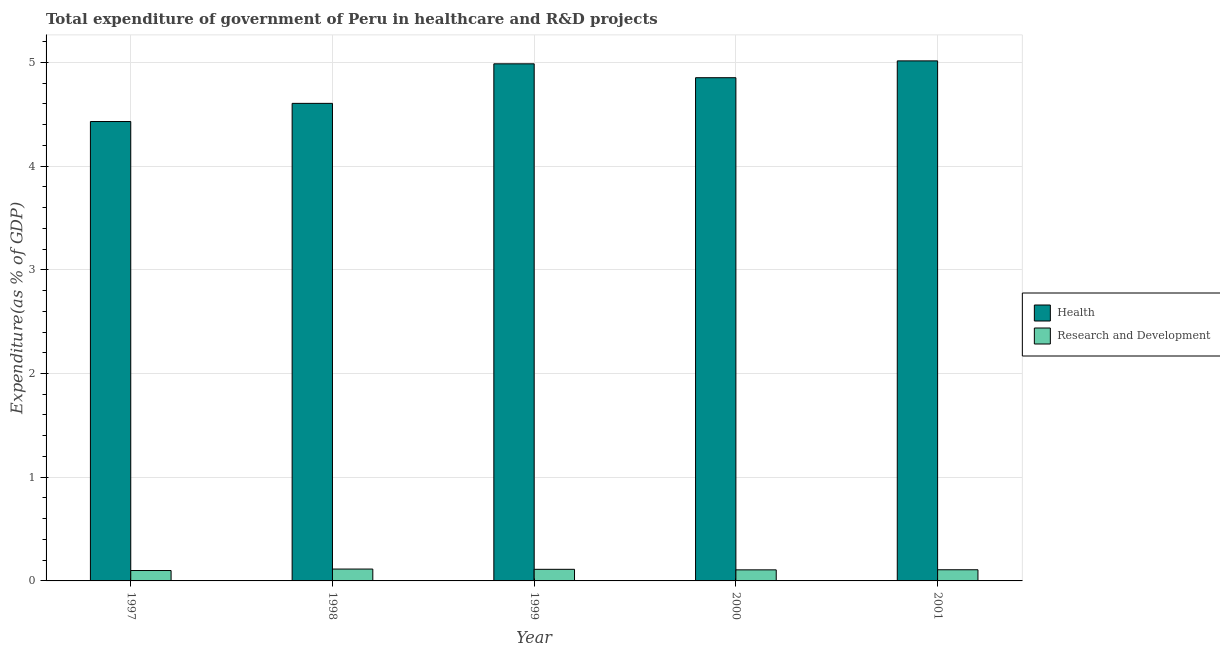How many groups of bars are there?
Keep it short and to the point. 5. Are the number of bars on each tick of the X-axis equal?
Provide a short and direct response. Yes. In how many cases, is the number of bars for a given year not equal to the number of legend labels?
Keep it short and to the point. 0. What is the expenditure in healthcare in 2000?
Your answer should be very brief. 4.85. Across all years, what is the maximum expenditure in r&d?
Your answer should be very brief. 0.11. Across all years, what is the minimum expenditure in r&d?
Your answer should be very brief. 0.1. In which year was the expenditure in healthcare maximum?
Provide a succinct answer. 2001. What is the total expenditure in healthcare in the graph?
Give a very brief answer. 23.89. What is the difference between the expenditure in r&d in 1999 and that in 2000?
Keep it short and to the point. 0.01. What is the difference between the expenditure in healthcare in 1998 and the expenditure in r&d in 1999?
Your answer should be compact. -0.38. What is the average expenditure in healthcare per year?
Your response must be concise. 4.78. In the year 2000, what is the difference between the expenditure in r&d and expenditure in healthcare?
Your answer should be very brief. 0. In how many years, is the expenditure in r&d greater than 2.2 %?
Keep it short and to the point. 0. What is the ratio of the expenditure in r&d in 2000 to that in 2001?
Your answer should be compact. 0.99. Is the expenditure in r&d in 1998 less than that in 2000?
Offer a terse response. No. What is the difference between the highest and the second highest expenditure in healthcare?
Give a very brief answer. 0.03. What is the difference between the highest and the lowest expenditure in healthcare?
Offer a terse response. 0.58. In how many years, is the expenditure in r&d greater than the average expenditure in r&d taken over all years?
Offer a terse response. 2. What does the 2nd bar from the left in 2000 represents?
Your answer should be compact. Research and Development. What does the 1st bar from the right in 2001 represents?
Give a very brief answer. Research and Development. How many bars are there?
Give a very brief answer. 10. Are the values on the major ticks of Y-axis written in scientific E-notation?
Give a very brief answer. No. Does the graph contain any zero values?
Make the answer very short. No. Does the graph contain grids?
Provide a succinct answer. Yes. What is the title of the graph?
Provide a succinct answer. Total expenditure of government of Peru in healthcare and R&D projects. Does "GDP at market prices" appear as one of the legend labels in the graph?
Offer a very short reply. No. What is the label or title of the Y-axis?
Provide a short and direct response. Expenditure(as % of GDP). What is the Expenditure(as % of GDP) of Health in 1997?
Your answer should be very brief. 4.43. What is the Expenditure(as % of GDP) in Research and Development in 1997?
Offer a terse response. 0.1. What is the Expenditure(as % of GDP) of Health in 1998?
Your response must be concise. 4.6. What is the Expenditure(as % of GDP) of Research and Development in 1998?
Provide a succinct answer. 0.11. What is the Expenditure(as % of GDP) of Health in 1999?
Offer a very short reply. 4.99. What is the Expenditure(as % of GDP) in Research and Development in 1999?
Make the answer very short. 0.11. What is the Expenditure(as % of GDP) in Health in 2000?
Ensure brevity in your answer.  4.85. What is the Expenditure(as % of GDP) in Research and Development in 2000?
Your answer should be compact. 0.11. What is the Expenditure(as % of GDP) of Health in 2001?
Your answer should be compact. 5.01. What is the Expenditure(as % of GDP) in Research and Development in 2001?
Ensure brevity in your answer.  0.11. Across all years, what is the maximum Expenditure(as % of GDP) of Health?
Provide a short and direct response. 5.01. Across all years, what is the maximum Expenditure(as % of GDP) in Research and Development?
Keep it short and to the point. 0.11. Across all years, what is the minimum Expenditure(as % of GDP) of Health?
Keep it short and to the point. 4.43. Across all years, what is the minimum Expenditure(as % of GDP) in Research and Development?
Offer a very short reply. 0.1. What is the total Expenditure(as % of GDP) of Health in the graph?
Your answer should be compact. 23.89. What is the total Expenditure(as % of GDP) in Research and Development in the graph?
Offer a terse response. 0.54. What is the difference between the Expenditure(as % of GDP) in Health in 1997 and that in 1998?
Keep it short and to the point. -0.17. What is the difference between the Expenditure(as % of GDP) of Research and Development in 1997 and that in 1998?
Make the answer very short. -0.01. What is the difference between the Expenditure(as % of GDP) of Health in 1997 and that in 1999?
Keep it short and to the point. -0.56. What is the difference between the Expenditure(as % of GDP) of Research and Development in 1997 and that in 1999?
Provide a short and direct response. -0.01. What is the difference between the Expenditure(as % of GDP) of Health in 1997 and that in 2000?
Your answer should be compact. -0.42. What is the difference between the Expenditure(as % of GDP) in Research and Development in 1997 and that in 2000?
Give a very brief answer. -0.01. What is the difference between the Expenditure(as % of GDP) in Health in 1997 and that in 2001?
Your answer should be compact. -0.58. What is the difference between the Expenditure(as % of GDP) of Research and Development in 1997 and that in 2001?
Provide a succinct answer. -0.01. What is the difference between the Expenditure(as % of GDP) of Health in 1998 and that in 1999?
Make the answer very short. -0.38. What is the difference between the Expenditure(as % of GDP) in Research and Development in 1998 and that in 1999?
Make the answer very short. 0. What is the difference between the Expenditure(as % of GDP) of Health in 1998 and that in 2000?
Make the answer very short. -0.25. What is the difference between the Expenditure(as % of GDP) in Research and Development in 1998 and that in 2000?
Ensure brevity in your answer.  0.01. What is the difference between the Expenditure(as % of GDP) in Health in 1998 and that in 2001?
Keep it short and to the point. -0.41. What is the difference between the Expenditure(as % of GDP) in Research and Development in 1998 and that in 2001?
Make the answer very short. 0.01. What is the difference between the Expenditure(as % of GDP) of Health in 1999 and that in 2000?
Provide a short and direct response. 0.13. What is the difference between the Expenditure(as % of GDP) in Research and Development in 1999 and that in 2000?
Your answer should be compact. 0.01. What is the difference between the Expenditure(as % of GDP) in Health in 1999 and that in 2001?
Provide a succinct answer. -0.03. What is the difference between the Expenditure(as % of GDP) of Research and Development in 1999 and that in 2001?
Offer a terse response. 0. What is the difference between the Expenditure(as % of GDP) of Health in 2000 and that in 2001?
Provide a short and direct response. -0.16. What is the difference between the Expenditure(as % of GDP) in Research and Development in 2000 and that in 2001?
Your answer should be very brief. -0. What is the difference between the Expenditure(as % of GDP) in Health in 1997 and the Expenditure(as % of GDP) in Research and Development in 1998?
Your answer should be compact. 4.32. What is the difference between the Expenditure(as % of GDP) in Health in 1997 and the Expenditure(as % of GDP) in Research and Development in 1999?
Offer a very short reply. 4.32. What is the difference between the Expenditure(as % of GDP) of Health in 1997 and the Expenditure(as % of GDP) of Research and Development in 2000?
Your answer should be compact. 4.32. What is the difference between the Expenditure(as % of GDP) in Health in 1997 and the Expenditure(as % of GDP) in Research and Development in 2001?
Your answer should be compact. 4.32. What is the difference between the Expenditure(as % of GDP) in Health in 1998 and the Expenditure(as % of GDP) in Research and Development in 1999?
Keep it short and to the point. 4.49. What is the difference between the Expenditure(as % of GDP) in Health in 1998 and the Expenditure(as % of GDP) in Research and Development in 2000?
Give a very brief answer. 4.5. What is the difference between the Expenditure(as % of GDP) in Health in 1998 and the Expenditure(as % of GDP) in Research and Development in 2001?
Offer a terse response. 4.5. What is the difference between the Expenditure(as % of GDP) of Health in 1999 and the Expenditure(as % of GDP) of Research and Development in 2000?
Your response must be concise. 4.88. What is the difference between the Expenditure(as % of GDP) of Health in 1999 and the Expenditure(as % of GDP) of Research and Development in 2001?
Ensure brevity in your answer.  4.88. What is the difference between the Expenditure(as % of GDP) in Health in 2000 and the Expenditure(as % of GDP) in Research and Development in 2001?
Your answer should be compact. 4.74. What is the average Expenditure(as % of GDP) in Health per year?
Your response must be concise. 4.78. What is the average Expenditure(as % of GDP) of Research and Development per year?
Provide a succinct answer. 0.11. In the year 1997, what is the difference between the Expenditure(as % of GDP) of Health and Expenditure(as % of GDP) of Research and Development?
Ensure brevity in your answer.  4.33. In the year 1998, what is the difference between the Expenditure(as % of GDP) of Health and Expenditure(as % of GDP) of Research and Development?
Give a very brief answer. 4.49. In the year 1999, what is the difference between the Expenditure(as % of GDP) in Health and Expenditure(as % of GDP) in Research and Development?
Ensure brevity in your answer.  4.87. In the year 2000, what is the difference between the Expenditure(as % of GDP) in Health and Expenditure(as % of GDP) in Research and Development?
Ensure brevity in your answer.  4.75. In the year 2001, what is the difference between the Expenditure(as % of GDP) of Health and Expenditure(as % of GDP) of Research and Development?
Provide a short and direct response. 4.91. What is the ratio of the Expenditure(as % of GDP) in Health in 1997 to that in 1998?
Give a very brief answer. 0.96. What is the ratio of the Expenditure(as % of GDP) in Research and Development in 1997 to that in 1998?
Offer a terse response. 0.88. What is the ratio of the Expenditure(as % of GDP) in Health in 1997 to that in 1999?
Provide a succinct answer. 0.89. What is the ratio of the Expenditure(as % of GDP) in Research and Development in 1997 to that in 1999?
Provide a succinct answer. 0.9. What is the ratio of the Expenditure(as % of GDP) in Health in 1997 to that in 2000?
Give a very brief answer. 0.91. What is the ratio of the Expenditure(as % of GDP) of Research and Development in 1997 to that in 2000?
Keep it short and to the point. 0.94. What is the ratio of the Expenditure(as % of GDP) of Health in 1997 to that in 2001?
Provide a short and direct response. 0.88. What is the ratio of the Expenditure(as % of GDP) of Research and Development in 1997 to that in 2001?
Make the answer very short. 0.93. What is the ratio of the Expenditure(as % of GDP) in Health in 1998 to that in 1999?
Give a very brief answer. 0.92. What is the ratio of the Expenditure(as % of GDP) of Research and Development in 1998 to that in 1999?
Your answer should be very brief. 1.02. What is the ratio of the Expenditure(as % of GDP) in Health in 1998 to that in 2000?
Your answer should be compact. 0.95. What is the ratio of the Expenditure(as % of GDP) of Research and Development in 1998 to that in 2000?
Ensure brevity in your answer.  1.07. What is the ratio of the Expenditure(as % of GDP) in Health in 1998 to that in 2001?
Give a very brief answer. 0.92. What is the ratio of the Expenditure(as % of GDP) in Research and Development in 1998 to that in 2001?
Make the answer very short. 1.06. What is the ratio of the Expenditure(as % of GDP) of Health in 1999 to that in 2000?
Your response must be concise. 1.03. What is the ratio of the Expenditure(as % of GDP) in Research and Development in 1999 to that in 2000?
Provide a succinct answer. 1.05. What is the ratio of the Expenditure(as % of GDP) in Health in 1999 to that in 2001?
Give a very brief answer. 0.99. What is the ratio of the Expenditure(as % of GDP) in Research and Development in 1999 to that in 2001?
Your answer should be very brief. 1.04. What is the ratio of the Expenditure(as % of GDP) in Health in 2000 to that in 2001?
Your answer should be very brief. 0.97. What is the ratio of the Expenditure(as % of GDP) of Research and Development in 2000 to that in 2001?
Give a very brief answer. 0.99. What is the difference between the highest and the second highest Expenditure(as % of GDP) in Health?
Offer a terse response. 0.03. What is the difference between the highest and the second highest Expenditure(as % of GDP) in Research and Development?
Provide a short and direct response. 0. What is the difference between the highest and the lowest Expenditure(as % of GDP) in Health?
Offer a terse response. 0.58. What is the difference between the highest and the lowest Expenditure(as % of GDP) in Research and Development?
Offer a very short reply. 0.01. 